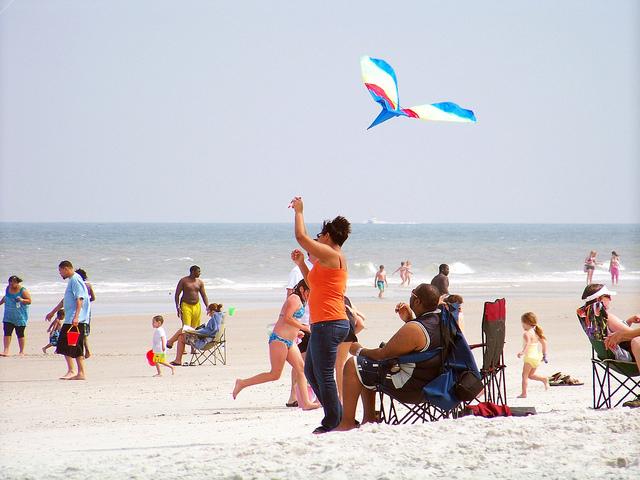Are all the people young and beautiful?
Write a very short answer. No. Who is carrying a red pail?
Concise answer only. Man. Where is the head scarf?
Write a very short answer. No head scarf. Are there any people in the water?
Short answer required. No. Is it a windy day?
Write a very short answer. Yes. 